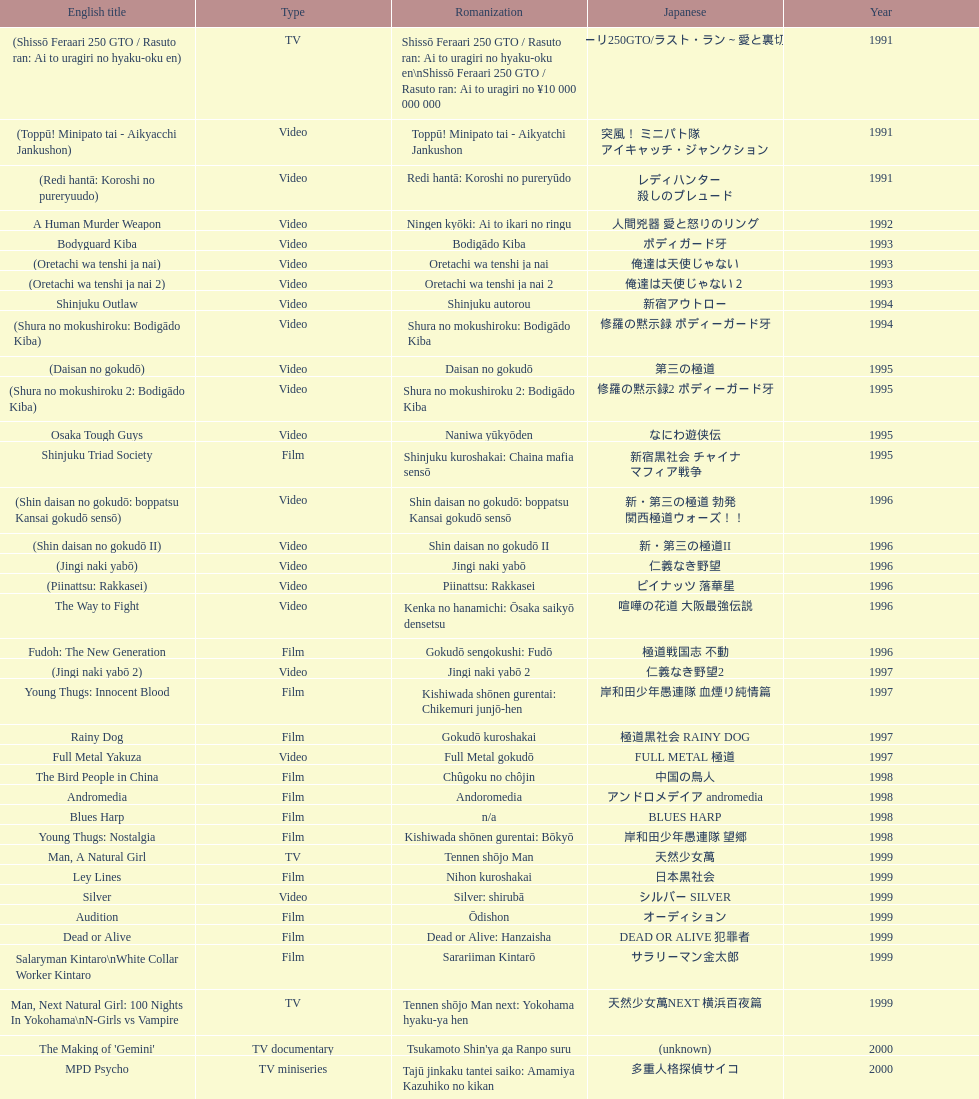Were more air on tv or video? Video. 